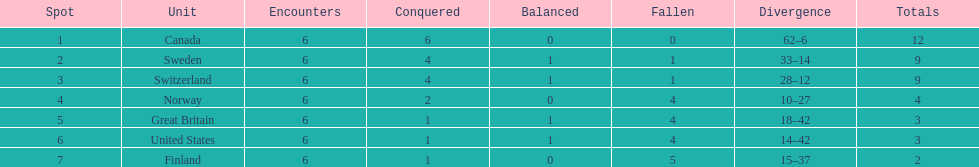Can you give me this table as a dict? {'header': ['Spot', 'Unit', 'Encounters', 'Conquered', 'Balanced', 'Fallen', 'Divergence', 'Totals'], 'rows': [['1', 'Canada', '6', '6', '0', '0', '62–6', '12'], ['2', 'Sweden', '6', '4', '1', '1', '33–14', '9'], ['3', 'Switzerland', '6', '4', '1', '1', '28–12', '9'], ['4', 'Norway', '6', '2', '0', '4', '10–27', '4'], ['5', 'Great Britain', '6', '1', '1', '4', '18–42', '3'], ['6', 'United States', '6', '1', '1', '4', '14–42', '3'], ['7', 'Finland', '6', '1', '0', '5', '15–37', '2']]} What team placed after canada? Sweden. 